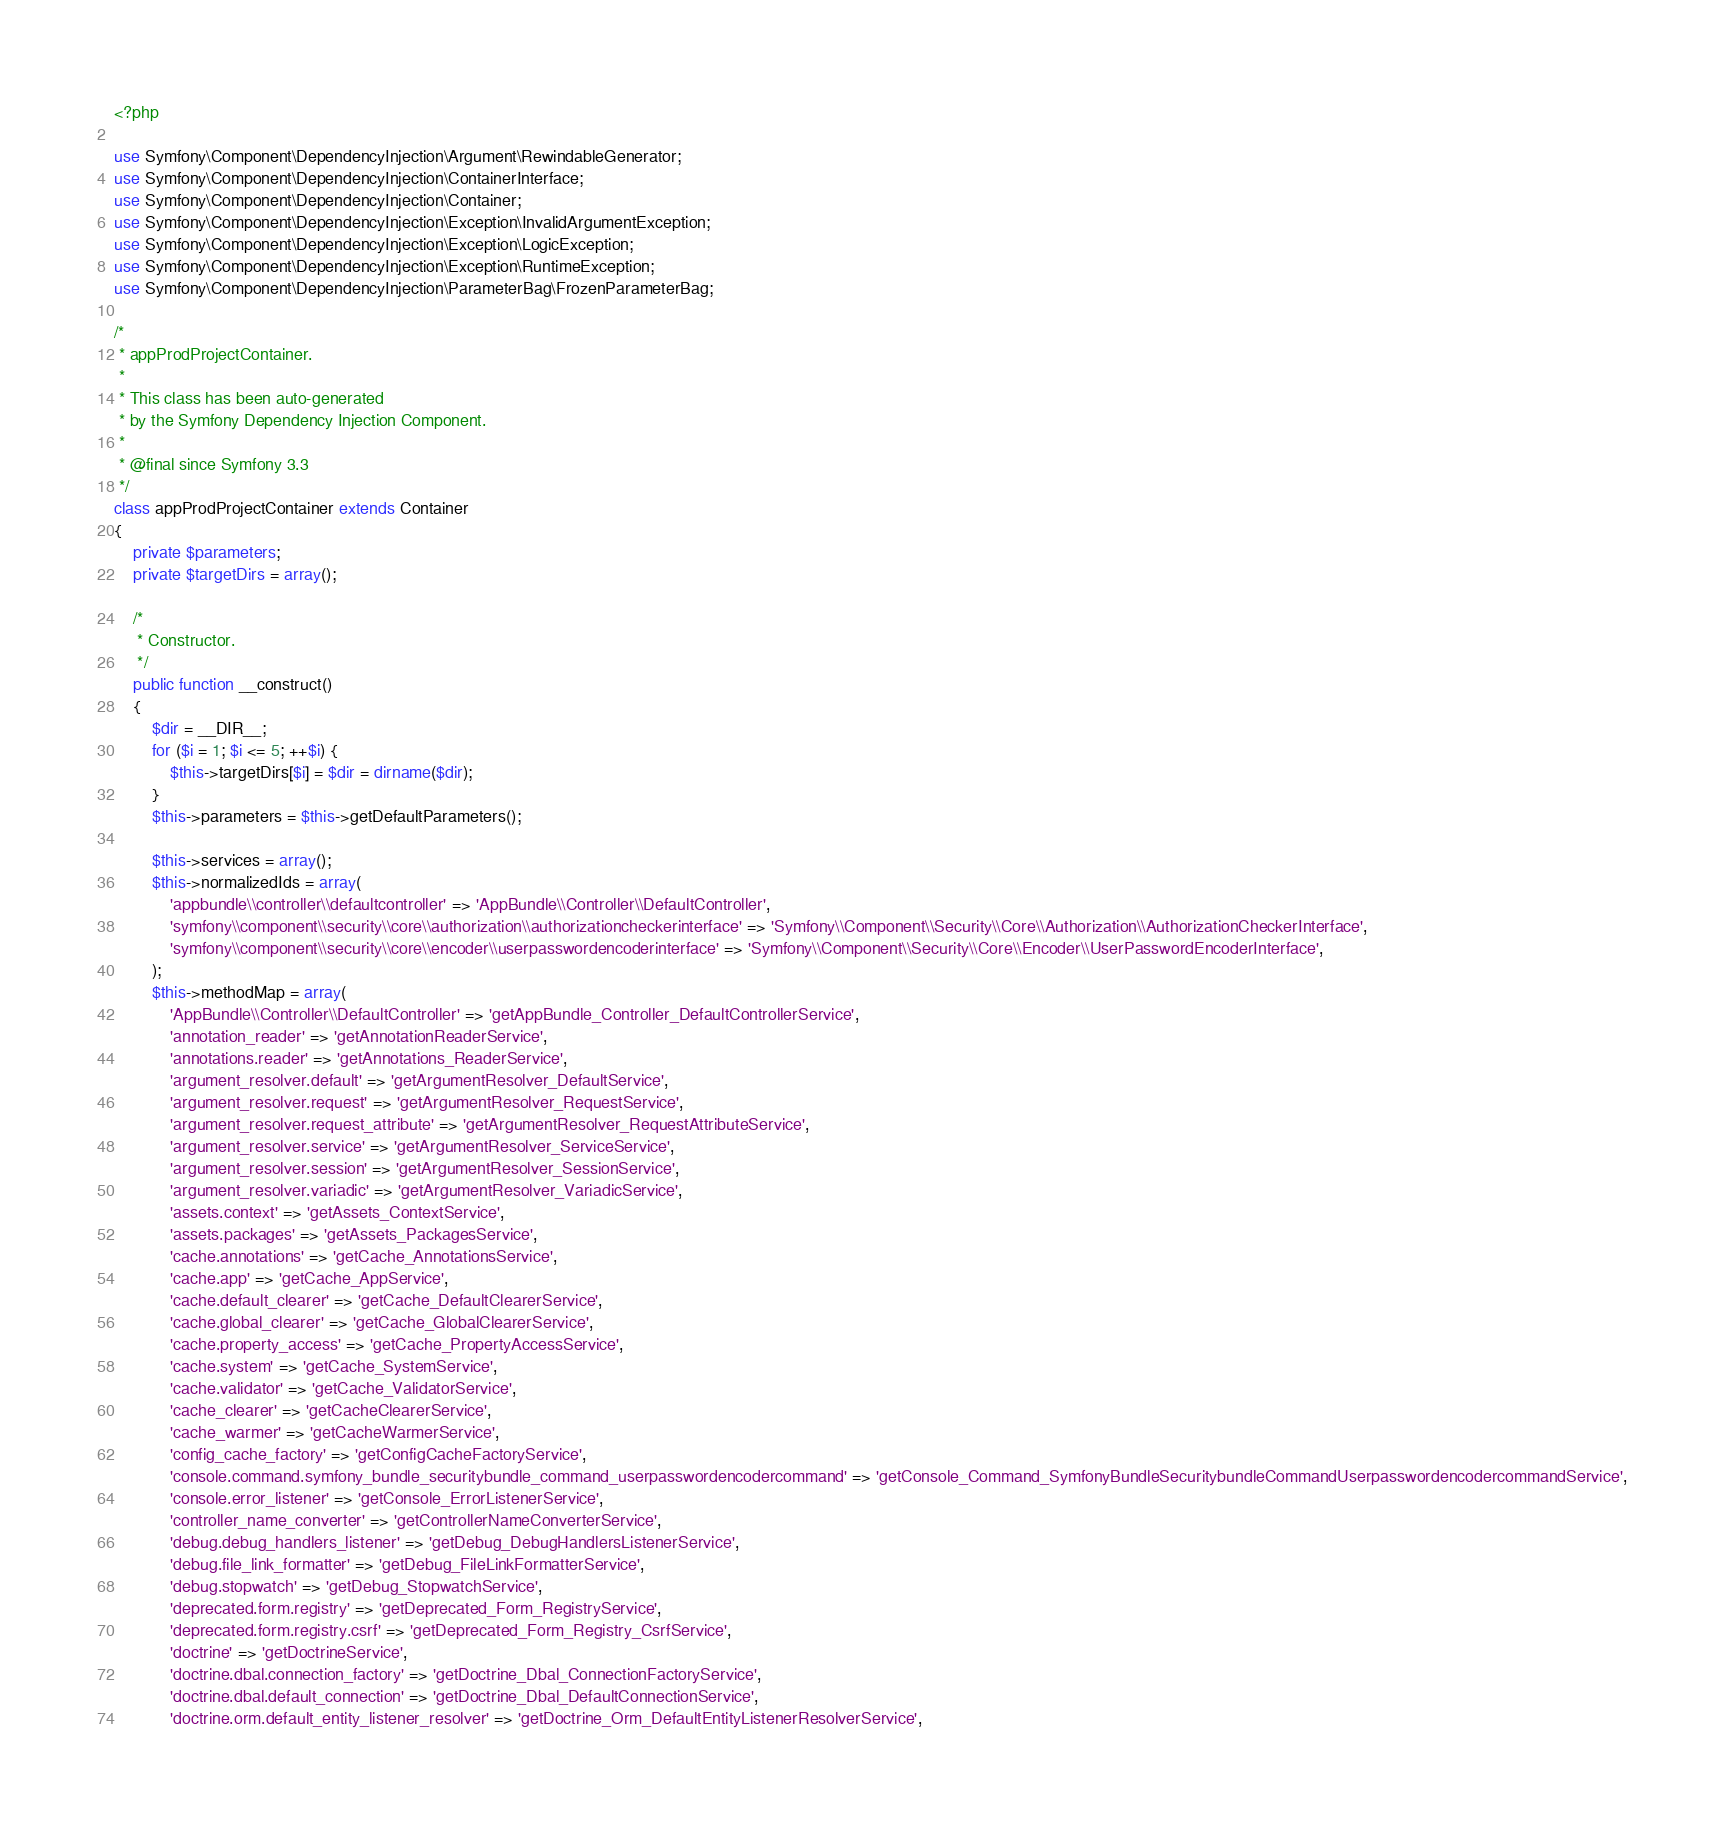Convert code to text. <code><loc_0><loc_0><loc_500><loc_500><_PHP_><?php

use Symfony\Component\DependencyInjection\Argument\RewindableGenerator;
use Symfony\Component\DependencyInjection\ContainerInterface;
use Symfony\Component\DependencyInjection\Container;
use Symfony\Component\DependencyInjection\Exception\InvalidArgumentException;
use Symfony\Component\DependencyInjection\Exception\LogicException;
use Symfony\Component\DependencyInjection\Exception\RuntimeException;
use Symfony\Component\DependencyInjection\ParameterBag\FrozenParameterBag;

/*
 * appProdProjectContainer.
 *
 * This class has been auto-generated
 * by the Symfony Dependency Injection Component.
 *
 * @final since Symfony 3.3
 */
class appProdProjectContainer extends Container
{
    private $parameters;
    private $targetDirs = array();

    /*
     * Constructor.
     */
    public function __construct()
    {
        $dir = __DIR__;
        for ($i = 1; $i <= 5; ++$i) {
            $this->targetDirs[$i] = $dir = dirname($dir);
        }
        $this->parameters = $this->getDefaultParameters();

        $this->services = array();
        $this->normalizedIds = array(
            'appbundle\\controller\\defaultcontroller' => 'AppBundle\\Controller\\DefaultController',
            'symfony\\component\\security\\core\\authorization\\authorizationcheckerinterface' => 'Symfony\\Component\\Security\\Core\\Authorization\\AuthorizationCheckerInterface',
            'symfony\\component\\security\\core\\encoder\\userpasswordencoderinterface' => 'Symfony\\Component\\Security\\Core\\Encoder\\UserPasswordEncoderInterface',
        );
        $this->methodMap = array(
            'AppBundle\\Controller\\DefaultController' => 'getAppBundle_Controller_DefaultControllerService',
            'annotation_reader' => 'getAnnotationReaderService',
            'annotations.reader' => 'getAnnotations_ReaderService',
            'argument_resolver.default' => 'getArgumentResolver_DefaultService',
            'argument_resolver.request' => 'getArgumentResolver_RequestService',
            'argument_resolver.request_attribute' => 'getArgumentResolver_RequestAttributeService',
            'argument_resolver.service' => 'getArgumentResolver_ServiceService',
            'argument_resolver.session' => 'getArgumentResolver_SessionService',
            'argument_resolver.variadic' => 'getArgumentResolver_VariadicService',
            'assets.context' => 'getAssets_ContextService',
            'assets.packages' => 'getAssets_PackagesService',
            'cache.annotations' => 'getCache_AnnotationsService',
            'cache.app' => 'getCache_AppService',
            'cache.default_clearer' => 'getCache_DefaultClearerService',
            'cache.global_clearer' => 'getCache_GlobalClearerService',
            'cache.property_access' => 'getCache_PropertyAccessService',
            'cache.system' => 'getCache_SystemService',
            'cache.validator' => 'getCache_ValidatorService',
            'cache_clearer' => 'getCacheClearerService',
            'cache_warmer' => 'getCacheWarmerService',
            'config_cache_factory' => 'getConfigCacheFactoryService',
            'console.command.symfony_bundle_securitybundle_command_userpasswordencodercommand' => 'getConsole_Command_SymfonyBundleSecuritybundleCommandUserpasswordencodercommandService',
            'console.error_listener' => 'getConsole_ErrorListenerService',
            'controller_name_converter' => 'getControllerNameConverterService',
            'debug.debug_handlers_listener' => 'getDebug_DebugHandlersListenerService',
            'debug.file_link_formatter' => 'getDebug_FileLinkFormatterService',
            'debug.stopwatch' => 'getDebug_StopwatchService',
            'deprecated.form.registry' => 'getDeprecated_Form_RegistryService',
            'deprecated.form.registry.csrf' => 'getDeprecated_Form_Registry_CsrfService',
            'doctrine' => 'getDoctrineService',
            'doctrine.dbal.connection_factory' => 'getDoctrine_Dbal_ConnectionFactoryService',
            'doctrine.dbal.default_connection' => 'getDoctrine_Dbal_DefaultConnectionService',
            'doctrine.orm.default_entity_listener_resolver' => 'getDoctrine_Orm_DefaultEntityListenerResolverService',</code> 